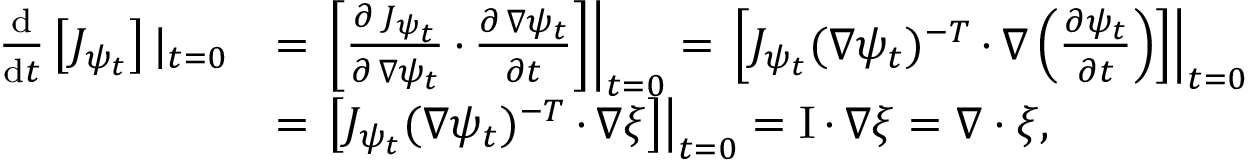<formula> <loc_0><loc_0><loc_500><loc_500>\begin{array} { r l } { \frac { d } { d t } \left [ J _ { \psi _ { t } } \right ] | _ { t = 0 } } & { = \left [ \frac { \partial \, J _ { \psi _ { t } } } { \partial \, \nabla \psi _ { t } } \, { \cdot } \, \frac { \partial \, \nabla \psi _ { t } } { \partial t } \right ] \right | _ { t = 0 } = \left [ J _ { \psi _ { t } } ( \nabla \psi _ { t } ) ^ { - T } \, { \cdot } \, \nabla \left ( \frac { \partial \psi _ { t } } { \partial t } \right ) \right ] \right | _ { t = 0 } } \\ & { = \left [ J _ { \psi _ { t } } ( \nabla \psi _ { t } ) ^ { - T } \, { \cdot } \, \nabla \xi \right ] \right | _ { t = 0 } = I \, { \cdot } \, \nabla \xi = \nabla \cdot \xi , } \end{array}</formula> 